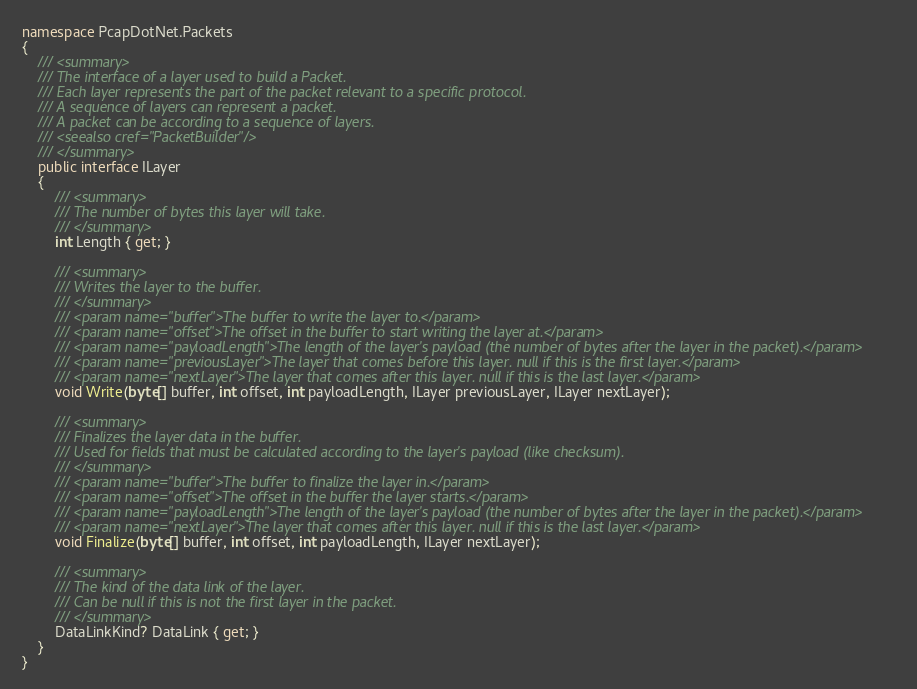<code> <loc_0><loc_0><loc_500><loc_500><_C#_>namespace PcapDotNet.Packets
{
    /// <summary>
    /// The interface of a layer used to build a Packet.
    /// Each layer represents the part of the packet relevant to a specific protocol.
    /// A sequence of layers can represent a packet.
    /// A packet can be according to a sequence of layers.
    /// <seealso cref="PacketBuilder"/>
    /// </summary>
    public interface ILayer
    {
        /// <summary>
        /// The number of bytes this layer will take.
        /// </summary>
        int Length { get; }

        /// <summary>
        /// Writes the layer to the buffer.
        /// </summary>
        /// <param name="buffer">The buffer to write the layer to.</param>
        /// <param name="offset">The offset in the buffer to start writing the layer at.</param>
        /// <param name="payloadLength">The length of the layer's payload (the number of bytes after the layer in the packet).</param>
        /// <param name="previousLayer">The layer that comes before this layer. null if this is the first layer.</param>
        /// <param name="nextLayer">The layer that comes after this layer. null if this is the last layer.</param>
        void Write(byte[] buffer, int offset, int payloadLength, ILayer previousLayer, ILayer nextLayer);

        /// <summary>
        /// Finalizes the layer data in the buffer.
        /// Used for fields that must be calculated according to the layer's payload (like checksum).
        /// </summary>
        /// <param name="buffer">The buffer to finalize the layer in.</param>
        /// <param name="offset">The offset in the buffer the layer starts.</param>
        /// <param name="payloadLength">The length of the layer's payload (the number of bytes after the layer in the packet).</param>
        /// <param name="nextLayer">The layer that comes after this layer. null if this is the last layer.</param>
        void Finalize(byte[] buffer, int offset, int payloadLength, ILayer nextLayer);

        /// <summary>
        /// The kind of the data link of the layer.
        /// Can be null if this is not the first layer in the packet.
        /// </summary>
        DataLinkKind? DataLink { get; }
    }
}</code> 